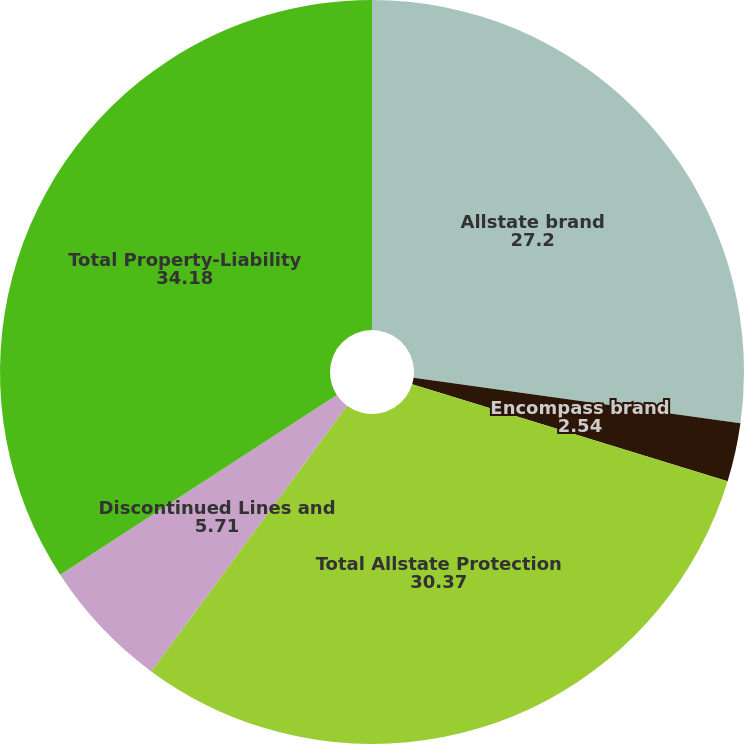Convert chart. <chart><loc_0><loc_0><loc_500><loc_500><pie_chart><fcel>Allstate brand<fcel>Encompass brand<fcel>Total Allstate Protection<fcel>Discontinued Lines and<fcel>Total Property-Liability<nl><fcel>27.2%<fcel>2.54%<fcel>30.37%<fcel>5.71%<fcel>34.18%<nl></chart> 